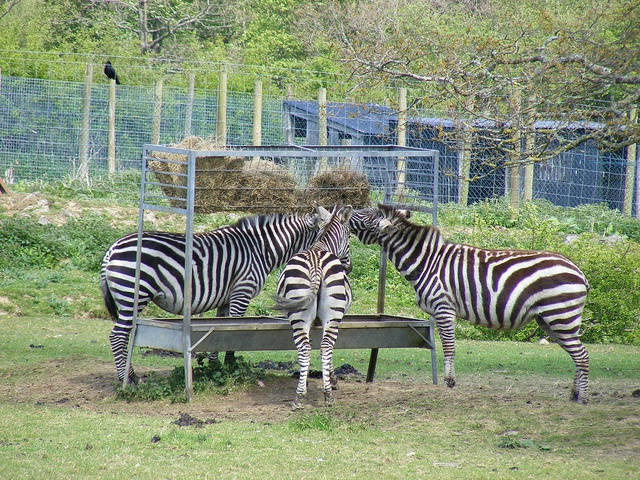Describe the objects in this image and their specific colors. I can see zebra in gray, black, lightgray, and darkgray tones, zebra in gray, black, darkgray, and lightgray tones, zebra in gray, lightgray, darkgray, and black tones, and bird in gray, black, navy, and darkgreen tones in this image. 